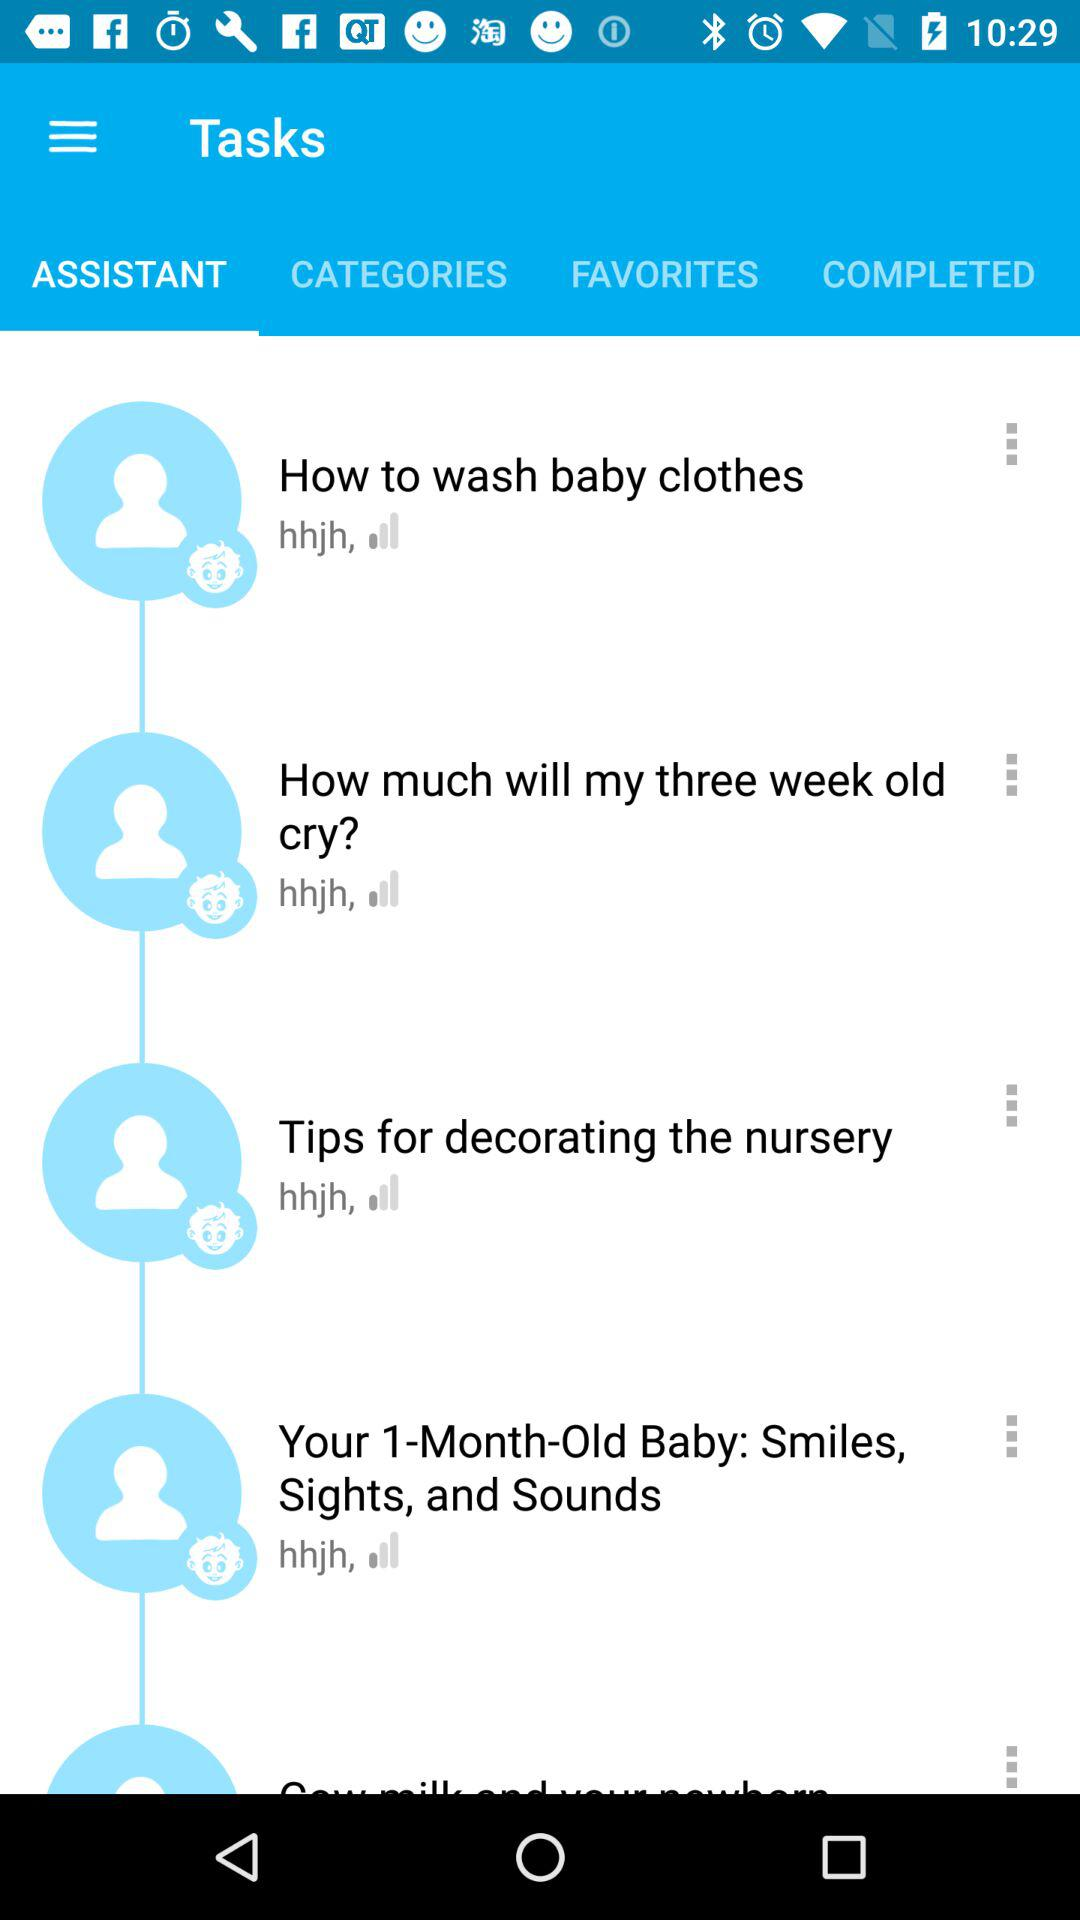Which tab is selected? The selected tab is Assistant. 